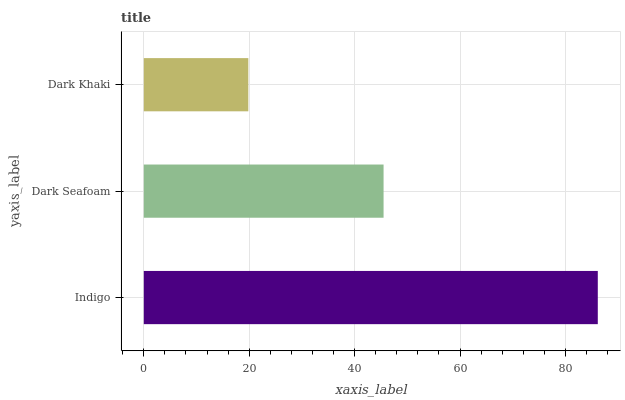Is Dark Khaki the minimum?
Answer yes or no. Yes. Is Indigo the maximum?
Answer yes or no. Yes. Is Dark Seafoam the minimum?
Answer yes or no. No. Is Dark Seafoam the maximum?
Answer yes or no. No. Is Indigo greater than Dark Seafoam?
Answer yes or no. Yes. Is Dark Seafoam less than Indigo?
Answer yes or no. Yes. Is Dark Seafoam greater than Indigo?
Answer yes or no. No. Is Indigo less than Dark Seafoam?
Answer yes or no. No. Is Dark Seafoam the high median?
Answer yes or no. Yes. Is Dark Seafoam the low median?
Answer yes or no. Yes. Is Dark Khaki the high median?
Answer yes or no. No. Is Dark Khaki the low median?
Answer yes or no. No. 